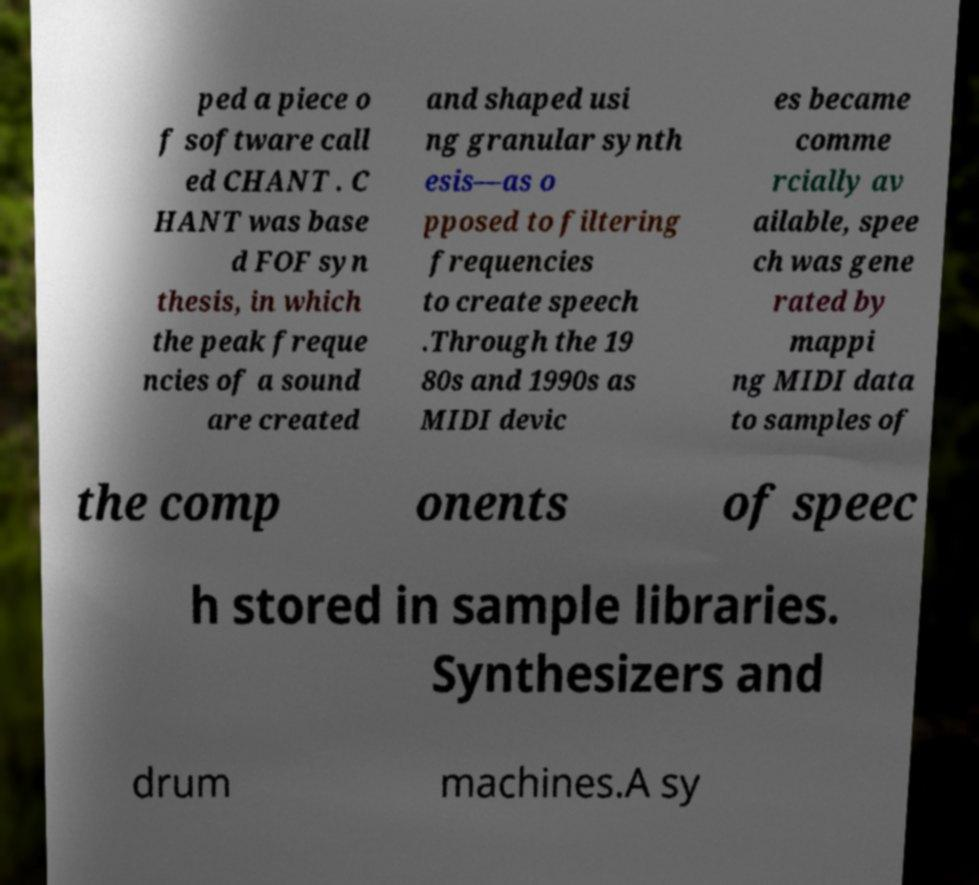For documentation purposes, I need the text within this image transcribed. Could you provide that? ped a piece o f software call ed CHANT . C HANT was base d FOF syn thesis, in which the peak freque ncies of a sound are created and shaped usi ng granular synth esis—as o pposed to filtering frequencies to create speech .Through the 19 80s and 1990s as MIDI devic es became comme rcially av ailable, spee ch was gene rated by mappi ng MIDI data to samples of the comp onents of speec h stored in sample libraries. Synthesizers and drum machines.A sy 